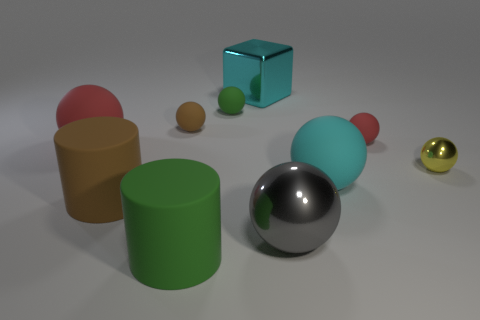What color is the other tiny metallic thing that is the same shape as the gray object?
Your answer should be compact. Yellow. There is a big rubber thing that is behind the tiny yellow sphere; is its color the same as the big rubber thing on the right side of the green cylinder?
Provide a short and direct response. No. Is the number of tiny yellow metal things left of the small brown matte ball greater than the number of spheres?
Keep it short and to the point. No. What number of other objects are the same size as the cyan sphere?
Make the answer very short. 5. How many large objects are to the right of the brown sphere and in front of the small brown rubber thing?
Your response must be concise. 3. Is the big green thing that is left of the green rubber sphere made of the same material as the big red object?
Keep it short and to the point. Yes. What shape is the large shiny object that is in front of the green thing that is on the right side of the green rubber thing that is in front of the brown cylinder?
Offer a very short reply. Sphere. Are there the same number of large red things that are to the left of the large red thing and small brown rubber balls to the left of the big brown rubber thing?
Offer a terse response. Yes. The shiny block that is the same size as the brown cylinder is what color?
Provide a short and direct response. Cyan. What number of big things are either brown matte spheres or matte spheres?
Your answer should be compact. 2. 